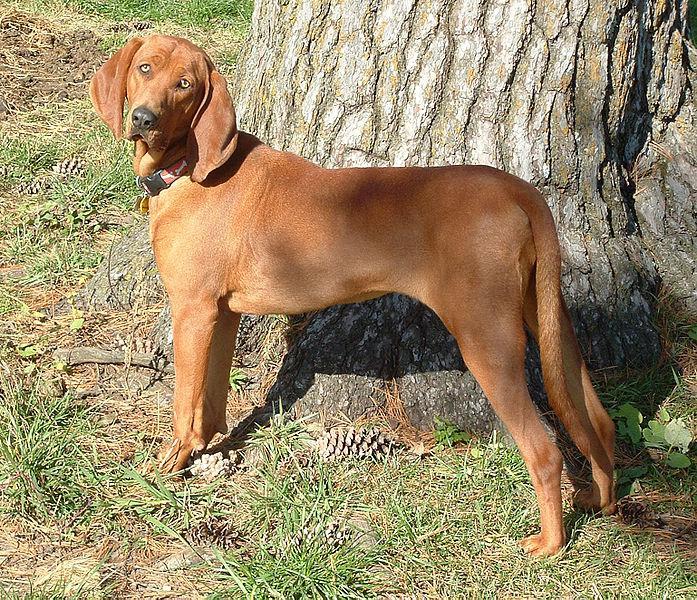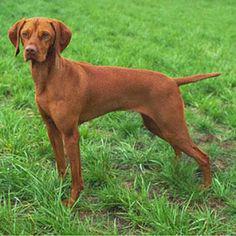The first image is the image on the left, the second image is the image on the right. For the images shown, is this caption "The left image contains one dog facing towards the right." true? Answer yes or no. No. 